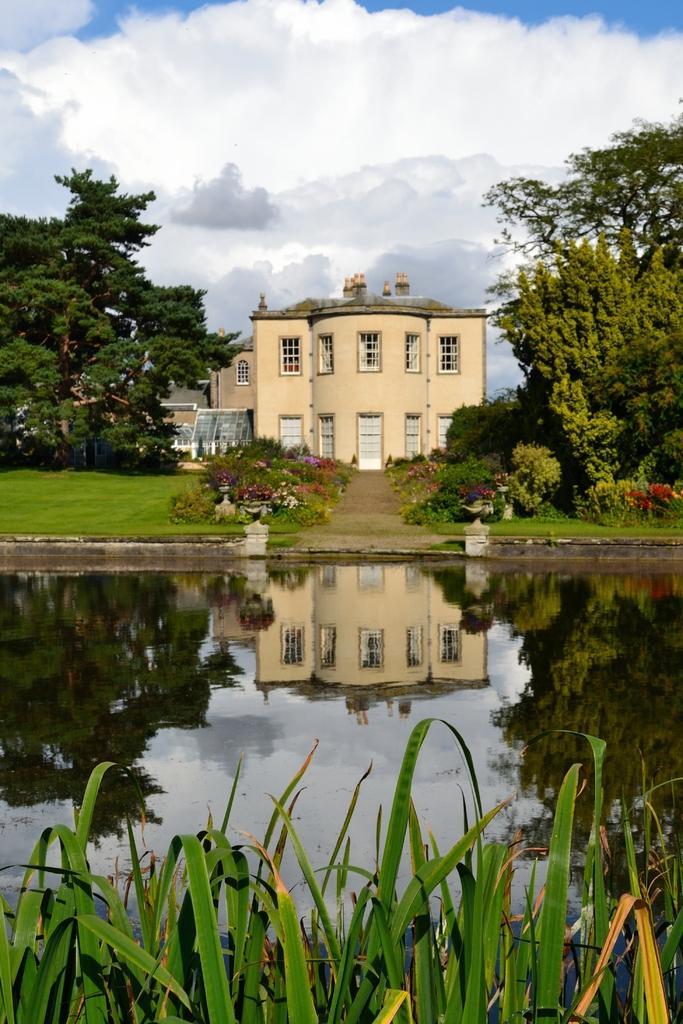How would you summarize this image in a sentence or two? In this picture we can observe a pond. There is some grass on the ground. We can observe some plants and trees. In the background there is a building and a sky with some clouds. 